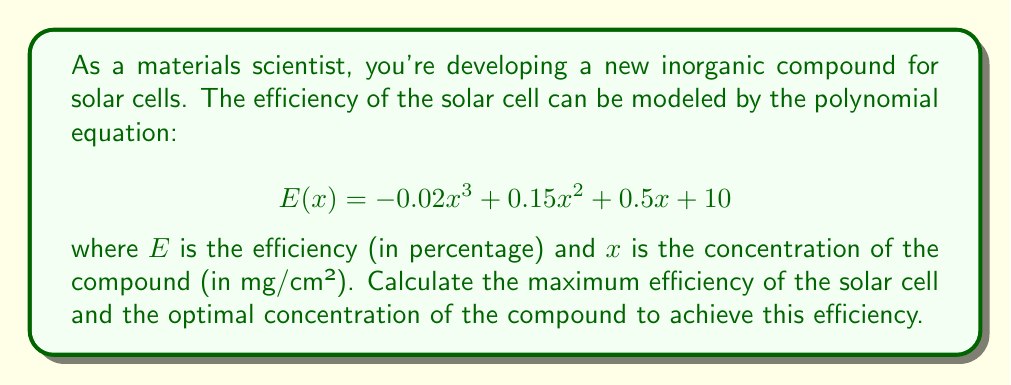What is the answer to this math problem? To find the maximum efficiency and optimal concentration, we need to follow these steps:

1) The maximum efficiency occurs at the point where the derivative of $E(x)$ equals zero. Let's find the derivative:

   $$E'(x) = -0.06x^2 + 0.3x + 0.5$$

2) Set $E'(x) = 0$ and solve for $x$:

   $$-0.06x^2 + 0.3x + 0.5 = 0$$

3) This is a quadratic equation. We can solve it using the quadratic formula:

   $$x = \frac{-b \pm \sqrt{b^2 - 4ac}}{2a}$$

   where $a = -0.06$, $b = 0.3$, and $c = 0.5$

4) Substituting these values:

   $$x = \frac{-0.3 \pm \sqrt{0.3^2 - 4(-0.06)(0.5)}}{2(-0.06)}$$

   $$x = \frac{-0.3 \pm \sqrt{0.09 + 0.12}}{-0.12}$$

   $$x = \frac{-0.3 \pm \sqrt{0.21}}{-0.12}$$

   $$x = \frac{-0.3 \pm 0.458}{-0.12}$$

5) This gives us two solutions:

   $$x_1 = \frac{-0.3 + 0.458}{-0.12} \approx 1.32$$
   $$x_2 = \frac{-0.3 - 0.458}{-0.12} \approx 6.32$$

6) To determine which of these gives the maximum (rather than minimum) efficiency, we can check the second derivative:

   $$E''(x) = -0.12x + 0.3$$

   At $x = 1.32$, $E''(1.32) = 0.1416 > 0$, indicating a local minimum.
   At $x = 6.32$, $E''(6.32) = -0.4584 < 0$, indicating a local maximum.

7) Therefore, the optimal concentration is approximately 6.32 mg/cm².

8) To find the maximum efficiency, we substitute this value back into our original equation:

   $$E(6.32) = -0.02(6.32)^3 + 0.15(6.32)^2 + 0.5(6.32) + 10$$

   $$= -0.02(252.54) + 0.15(39.94) + 0.5(6.32) + 10$$

   $$= -5.05 + 5.99 + 3.16 + 10$$

   $$= 14.1\%$$
Answer: The maximum efficiency of the solar cell is approximately 14.1%, achieved at an optimal compound concentration of 6.32 mg/cm². 